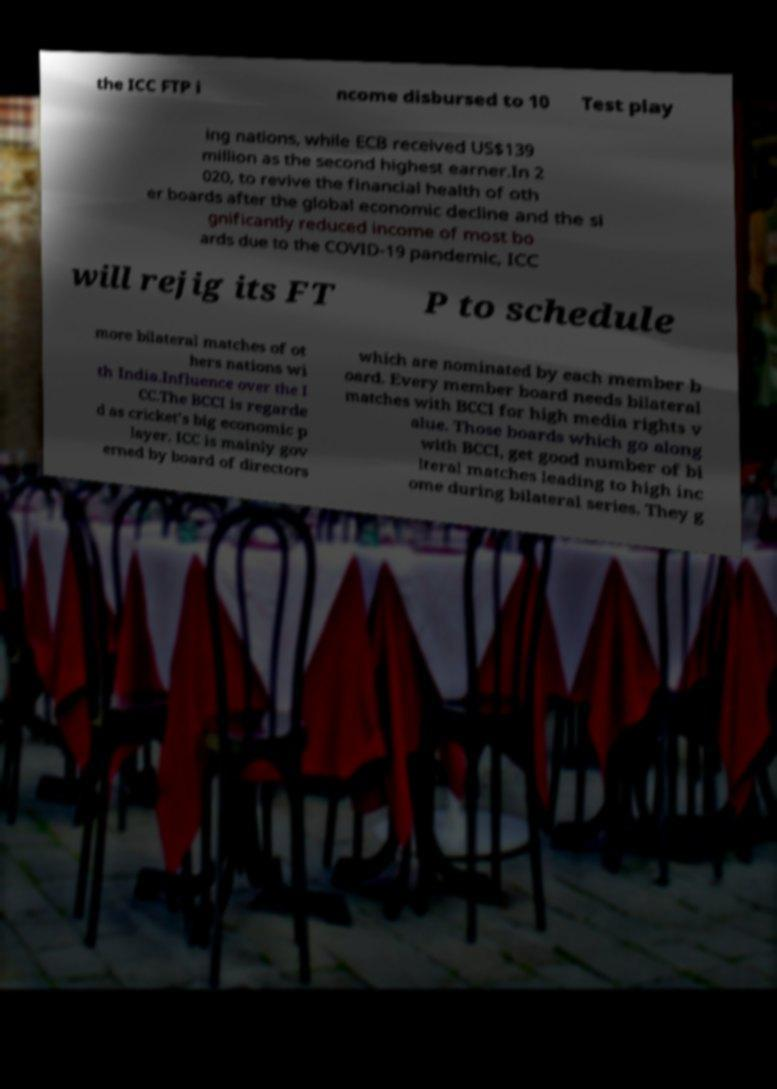Could you extract and type out the text from this image? the ICC FTP i ncome disbursed to 10 Test play ing nations, while ECB received US$139 million as the second highest earner.In 2 020, to revive the financial health of oth er boards after the global economic decline and the si gnificantly reduced income of most bo ards due to the COVID-19 pandemic, ICC will rejig its FT P to schedule more bilateral matches of ot hers nations wi th India.Influence over the I CC.The BCCI is regarde d as cricket's big economic p layer. ICC is mainly gov erned by board of directors which are nominated by each member b oard. Every member board needs bilateral matches with BCCI for high media rights v alue. Those boards which go along with BCCI, get good number of bi lteral matches leading to high inc ome during bilateral series. They g 